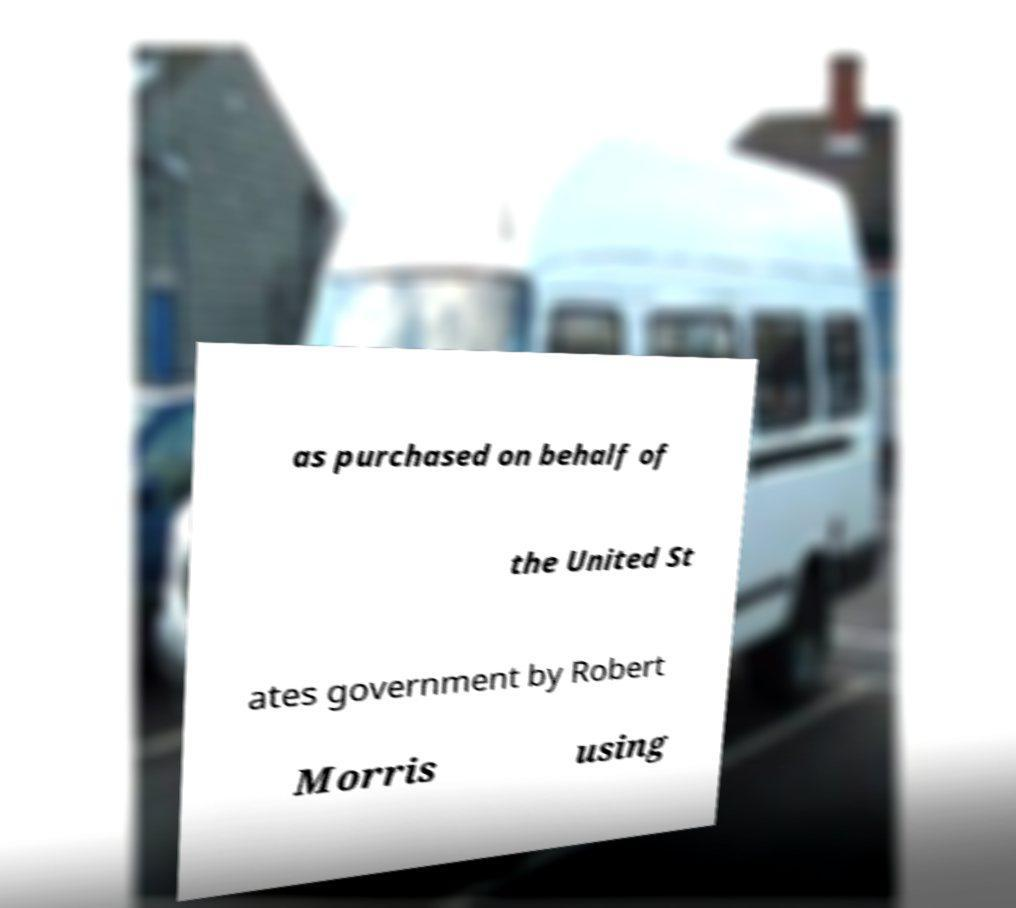For documentation purposes, I need the text within this image transcribed. Could you provide that? as purchased on behalf of the United St ates government by Robert Morris using 